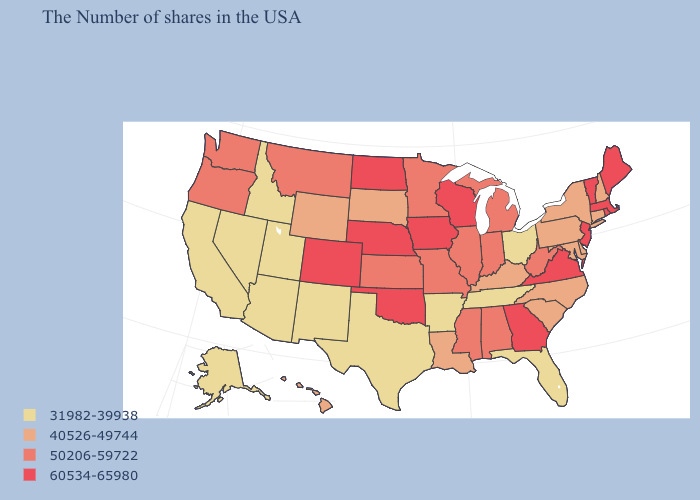Does the first symbol in the legend represent the smallest category?
Write a very short answer. Yes. Among the states that border Texas , which have the lowest value?
Give a very brief answer. Arkansas, New Mexico. Among the states that border South Dakota , does Iowa have the lowest value?
Keep it brief. No. Name the states that have a value in the range 31982-39938?
Concise answer only. Ohio, Florida, Tennessee, Arkansas, Texas, New Mexico, Utah, Arizona, Idaho, Nevada, California, Alaska. Is the legend a continuous bar?
Short answer required. No. What is the highest value in the Northeast ?
Give a very brief answer. 60534-65980. What is the value of Connecticut?
Short answer required. 40526-49744. Among the states that border Arkansas , which have the lowest value?
Write a very short answer. Tennessee, Texas. Among the states that border Nevada , which have the highest value?
Give a very brief answer. Oregon. What is the value of Maine?
Give a very brief answer. 60534-65980. What is the value of Texas?
Keep it brief. 31982-39938. Among the states that border Utah , does Colorado have the highest value?
Concise answer only. Yes. Does Nebraska have a higher value than Idaho?
Short answer required. Yes. Name the states that have a value in the range 50206-59722?
Give a very brief answer. West Virginia, Michigan, Indiana, Alabama, Illinois, Mississippi, Missouri, Minnesota, Kansas, Montana, Washington, Oregon. Does Michigan have a lower value than North Dakota?
Answer briefly. Yes. 